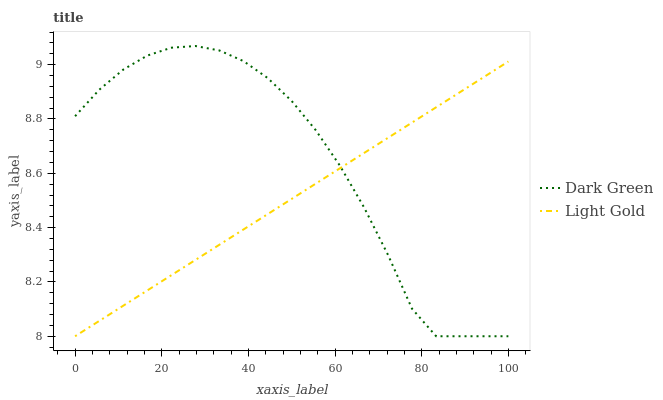Does Light Gold have the minimum area under the curve?
Answer yes or no. Yes. Does Dark Green have the maximum area under the curve?
Answer yes or no. Yes. Does Dark Green have the minimum area under the curve?
Answer yes or no. No. Is Light Gold the smoothest?
Answer yes or no. Yes. Is Dark Green the roughest?
Answer yes or no. Yes. Is Dark Green the smoothest?
Answer yes or no. No. 